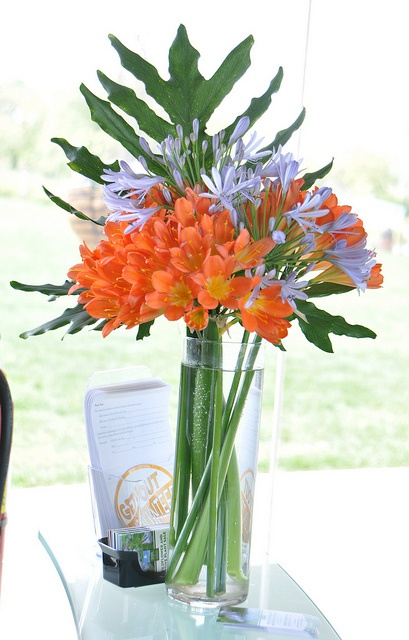Describe the objects in this image and their specific colors. I can see a vase in white, green, darkgray, and darkgreen tones in this image. 